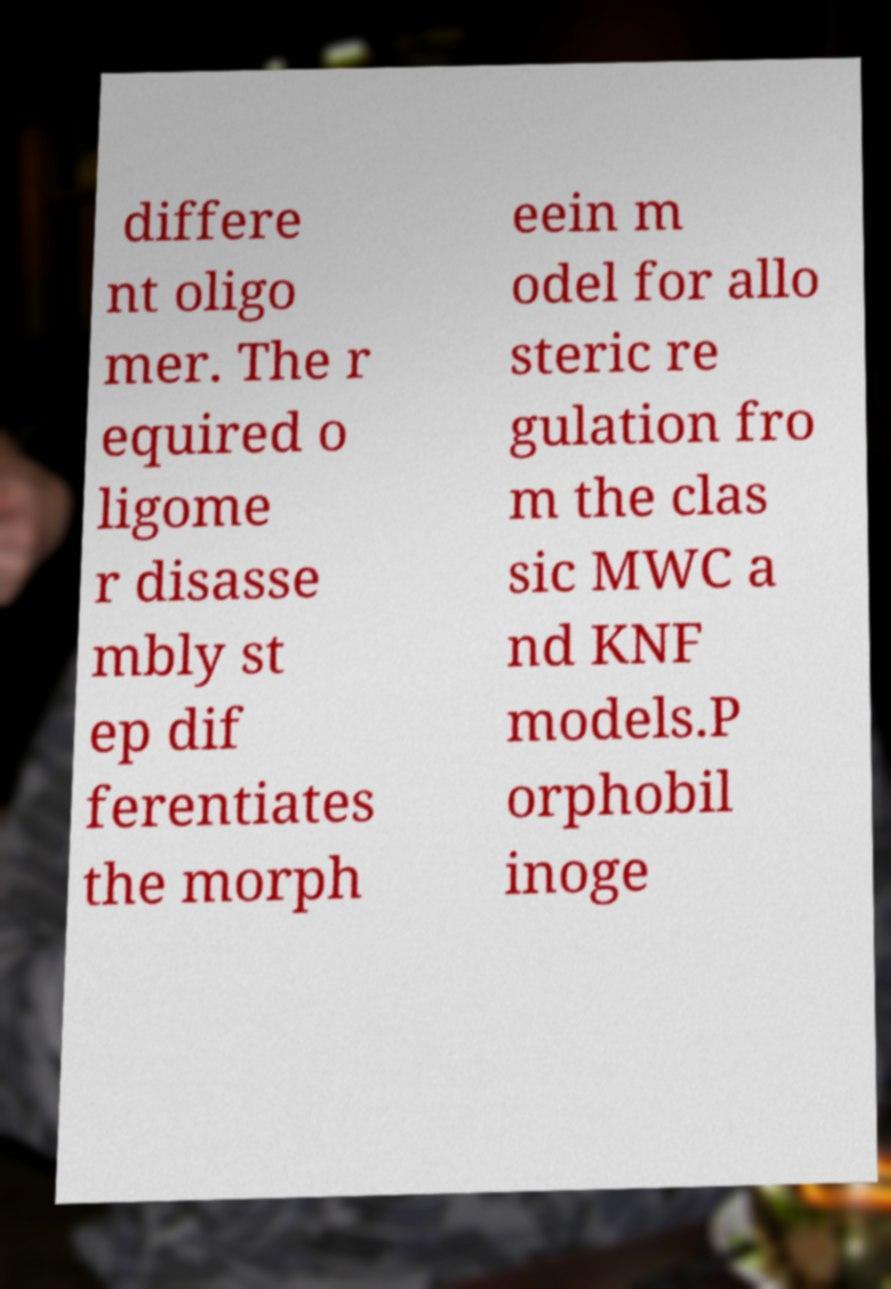What messages or text are displayed in this image? I need them in a readable, typed format. differe nt oligo mer. The r equired o ligome r disasse mbly st ep dif ferentiates the morph eein m odel for allo steric re gulation fro m the clas sic MWC a nd KNF models.P orphobil inoge 